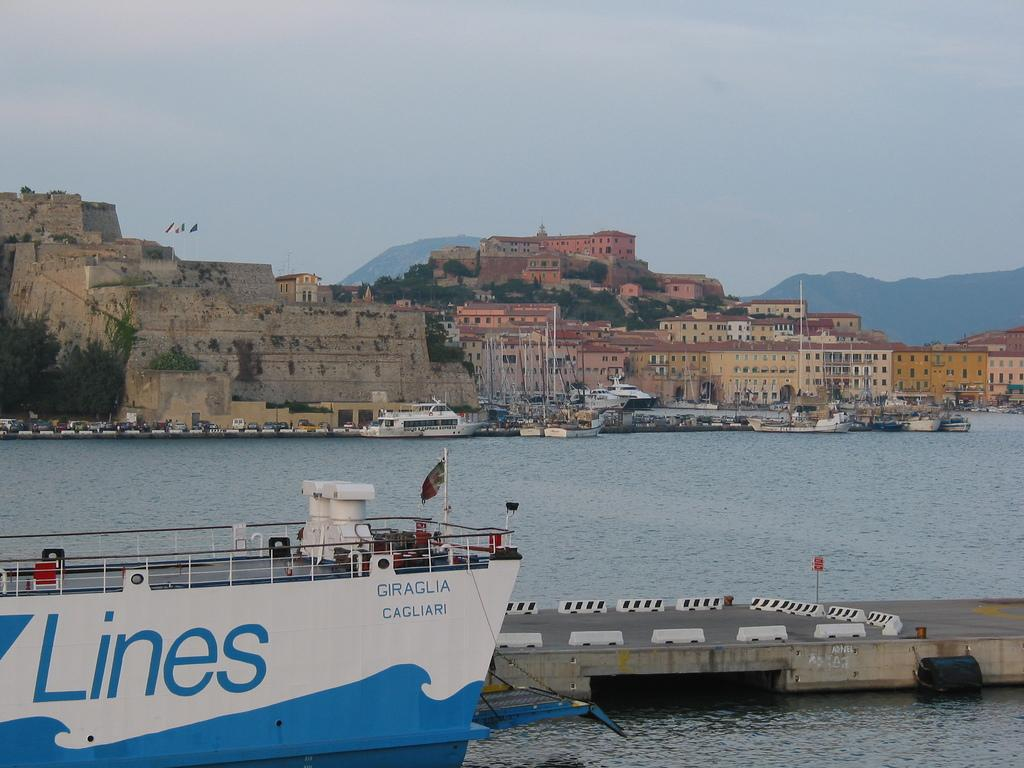What is the main subject of the image? The main subject of the image is a ship. What else can be seen in the water besides the ship? There are boats in the water. What structures are present in the image? There is a bridge, buildings, and trees in the image. What type of terrain is visible in the image? There are hills in the image. What is the condition of the sky in the image? The sky is cloudy in the image. Is there any text visible on the ship? Yes, there is text on the ship. What color is the crayon used to draw the bear on the blade in the image? There is no crayon, bear, or blade present in the image. 